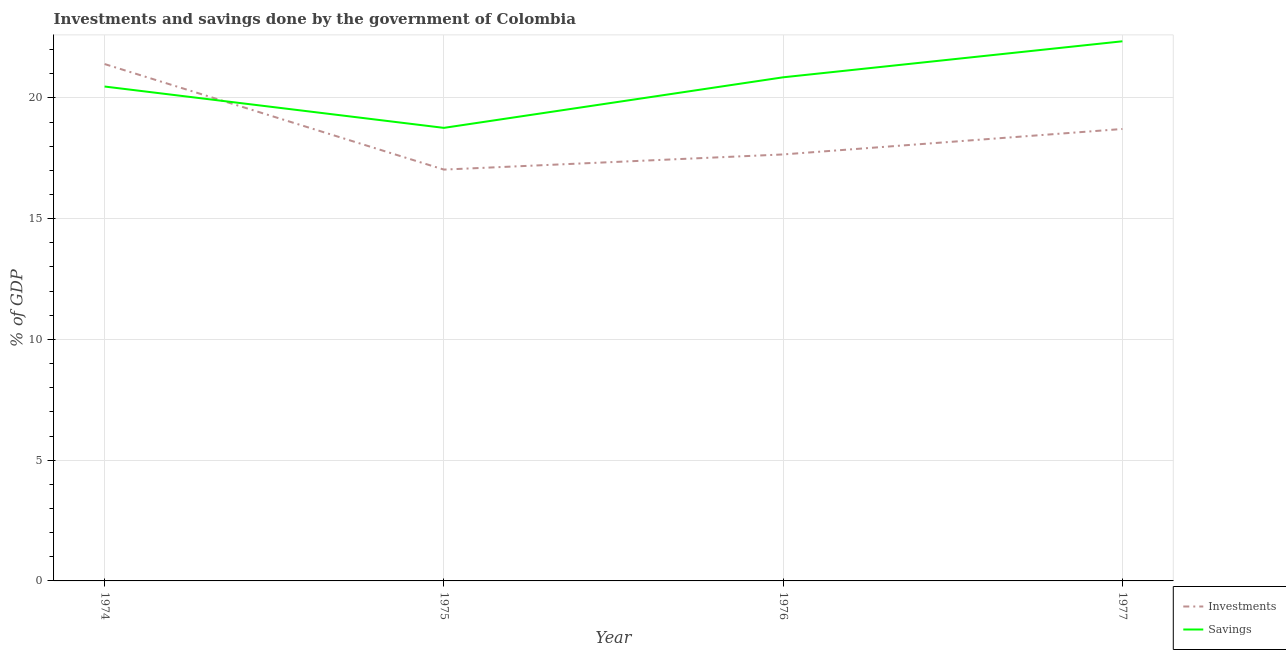Is the number of lines equal to the number of legend labels?
Your answer should be very brief. Yes. What is the savings of government in 1976?
Give a very brief answer. 20.85. Across all years, what is the maximum savings of government?
Your answer should be very brief. 22.35. Across all years, what is the minimum investments of government?
Offer a terse response. 17.03. In which year was the investments of government minimum?
Your answer should be compact. 1975. What is the total savings of government in the graph?
Your response must be concise. 82.43. What is the difference between the investments of government in 1974 and that in 1975?
Your answer should be very brief. 4.37. What is the difference between the investments of government in 1974 and the savings of government in 1976?
Ensure brevity in your answer.  0.55. What is the average savings of government per year?
Provide a succinct answer. 20.61. In the year 1976, what is the difference between the investments of government and savings of government?
Ensure brevity in your answer.  -3.19. What is the ratio of the savings of government in 1975 to that in 1977?
Keep it short and to the point. 0.84. Is the savings of government in 1974 less than that in 1975?
Keep it short and to the point. No. Is the difference between the savings of government in 1975 and 1977 greater than the difference between the investments of government in 1975 and 1977?
Your response must be concise. No. What is the difference between the highest and the second highest savings of government?
Ensure brevity in your answer.  1.49. What is the difference between the highest and the lowest investments of government?
Provide a succinct answer. 4.37. In how many years, is the savings of government greater than the average savings of government taken over all years?
Provide a succinct answer. 2. Does the savings of government monotonically increase over the years?
Keep it short and to the point. No. How many lines are there?
Keep it short and to the point. 2. Are the values on the major ticks of Y-axis written in scientific E-notation?
Keep it short and to the point. No. Does the graph contain any zero values?
Give a very brief answer. No. Does the graph contain grids?
Offer a very short reply. Yes. How many legend labels are there?
Offer a very short reply. 2. What is the title of the graph?
Your response must be concise. Investments and savings done by the government of Colombia. Does "Female entrants" appear as one of the legend labels in the graph?
Provide a short and direct response. No. What is the label or title of the X-axis?
Provide a succinct answer. Year. What is the label or title of the Y-axis?
Offer a very short reply. % of GDP. What is the % of GDP in Investments in 1974?
Provide a short and direct response. 21.4. What is the % of GDP in Savings in 1974?
Your response must be concise. 20.47. What is the % of GDP in Investments in 1975?
Your response must be concise. 17.03. What is the % of GDP in Savings in 1975?
Your response must be concise. 18.76. What is the % of GDP in Investments in 1976?
Your answer should be very brief. 17.66. What is the % of GDP in Savings in 1976?
Offer a very short reply. 20.85. What is the % of GDP of Investments in 1977?
Provide a short and direct response. 18.71. What is the % of GDP in Savings in 1977?
Make the answer very short. 22.35. Across all years, what is the maximum % of GDP of Investments?
Give a very brief answer. 21.4. Across all years, what is the maximum % of GDP in Savings?
Make the answer very short. 22.35. Across all years, what is the minimum % of GDP in Investments?
Your answer should be compact. 17.03. Across all years, what is the minimum % of GDP of Savings?
Ensure brevity in your answer.  18.76. What is the total % of GDP in Investments in the graph?
Provide a succinct answer. 74.81. What is the total % of GDP of Savings in the graph?
Give a very brief answer. 82.43. What is the difference between the % of GDP of Investments in 1974 and that in 1975?
Your answer should be very brief. 4.37. What is the difference between the % of GDP in Savings in 1974 and that in 1975?
Your response must be concise. 1.71. What is the difference between the % of GDP of Investments in 1974 and that in 1976?
Keep it short and to the point. 3.74. What is the difference between the % of GDP in Savings in 1974 and that in 1976?
Keep it short and to the point. -0.38. What is the difference between the % of GDP of Investments in 1974 and that in 1977?
Give a very brief answer. 2.69. What is the difference between the % of GDP of Savings in 1974 and that in 1977?
Give a very brief answer. -1.87. What is the difference between the % of GDP in Investments in 1975 and that in 1976?
Offer a terse response. -0.63. What is the difference between the % of GDP of Savings in 1975 and that in 1976?
Offer a terse response. -2.09. What is the difference between the % of GDP of Investments in 1975 and that in 1977?
Keep it short and to the point. -1.68. What is the difference between the % of GDP of Savings in 1975 and that in 1977?
Ensure brevity in your answer.  -3.58. What is the difference between the % of GDP in Investments in 1976 and that in 1977?
Offer a very short reply. -1.05. What is the difference between the % of GDP in Savings in 1976 and that in 1977?
Offer a terse response. -1.49. What is the difference between the % of GDP of Investments in 1974 and the % of GDP of Savings in 1975?
Ensure brevity in your answer.  2.64. What is the difference between the % of GDP of Investments in 1974 and the % of GDP of Savings in 1976?
Your response must be concise. 0.55. What is the difference between the % of GDP in Investments in 1974 and the % of GDP in Savings in 1977?
Your answer should be compact. -0.94. What is the difference between the % of GDP in Investments in 1975 and the % of GDP in Savings in 1976?
Your answer should be compact. -3.82. What is the difference between the % of GDP in Investments in 1975 and the % of GDP in Savings in 1977?
Give a very brief answer. -5.31. What is the difference between the % of GDP in Investments in 1976 and the % of GDP in Savings in 1977?
Make the answer very short. -4.69. What is the average % of GDP of Investments per year?
Offer a very short reply. 18.7. What is the average % of GDP in Savings per year?
Ensure brevity in your answer.  20.61. In the year 1974, what is the difference between the % of GDP of Investments and % of GDP of Savings?
Keep it short and to the point. 0.93. In the year 1975, what is the difference between the % of GDP in Investments and % of GDP in Savings?
Offer a very short reply. -1.73. In the year 1976, what is the difference between the % of GDP in Investments and % of GDP in Savings?
Provide a short and direct response. -3.19. In the year 1977, what is the difference between the % of GDP of Investments and % of GDP of Savings?
Provide a succinct answer. -3.63. What is the ratio of the % of GDP of Investments in 1974 to that in 1975?
Provide a short and direct response. 1.26. What is the ratio of the % of GDP of Savings in 1974 to that in 1975?
Provide a succinct answer. 1.09. What is the ratio of the % of GDP of Investments in 1974 to that in 1976?
Your answer should be compact. 1.21. What is the ratio of the % of GDP of Savings in 1974 to that in 1976?
Your answer should be compact. 0.98. What is the ratio of the % of GDP of Investments in 1974 to that in 1977?
Your answer should be compact. 1.14. What is the ratio of the % of GDP in Savings in 1974 to that in 1977?
Offer a terse response. 0.92. What is the ratio of the % of GDP of Investments in 1975 to that in 1976?
Give a very brief answer. 0.96. What is the ratio of the % of GDP in Savings in 1975 to that in 1976?
Provide a succinct answer. 0.9. What is the ratio of the % of GDP of Investments in 1975 to that in 1977?
Offer a terse response. 0.91. What is the ratio of the % of GDP in Savings in 1975 to that in 1977?
Your answer should be very brief. 0.84. What is the ratio of the % of GDP in Investments in 1976 to that in 1977?
Offer a terse response. 0.94. What is the ratio of the % of GDP in Savings in 1976 to that in 1977?
Provide a short and direct response. 0.93. What is the difference between the highest and the second highest % of GDP of Investments?
Offer a very short reply. 2.69. What is the difference between the highest and the second highest % of GDP of Savings?
Ensure brevity in your answer.  1.49. What is the difference between the highest and the lowest % of GDP in Investments?
Ensure brevity in your answer.  4.37. What is the difference between the highest and the lowest % of GDP in Savings?
Your answer should be compact. 3.58. 